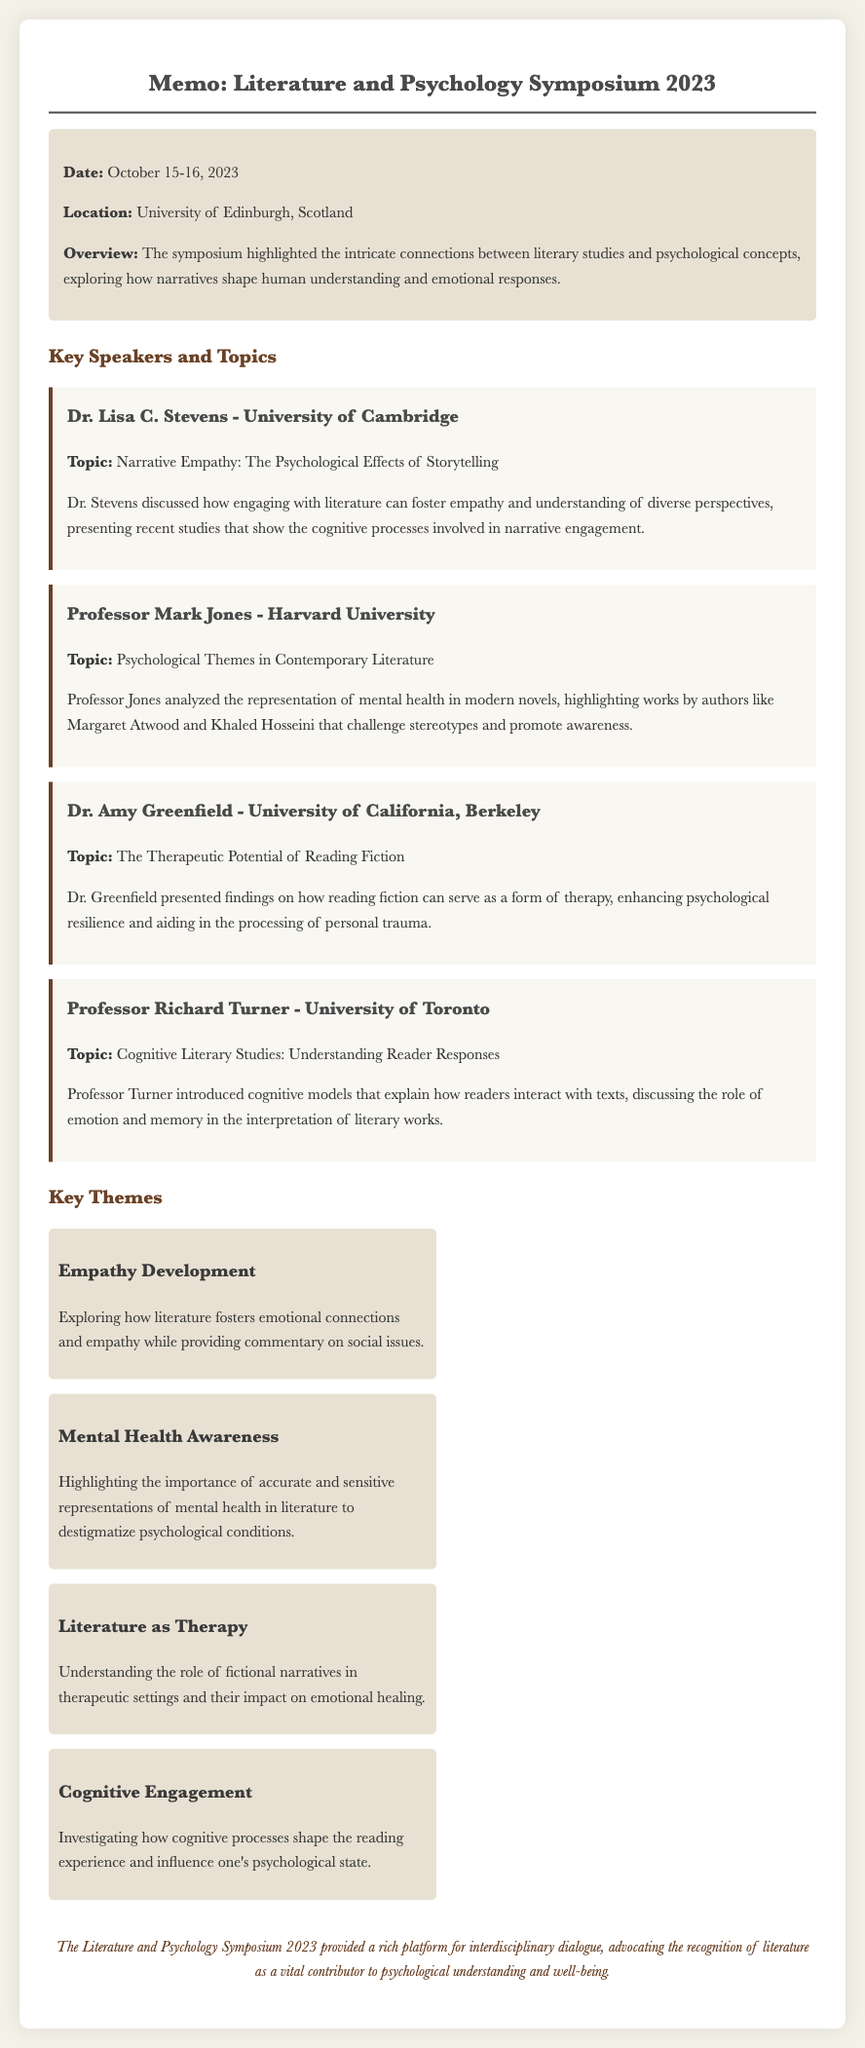What were the dates of the symposium? The dates of the symposium are mentioned in the document as October 15-16, 2023.
Answer: October 15-16, 2023 Who was the speaker from Harvard University? The document provides a list of speakers and identifies Professor Mark Jones as the speaker from Harvard University.
Answer: Professor Mark Jones What was Dr. Amy Greenfield's topic? The topic for Dr. Amy Greenfield is stated as "The Therapeutic Potential of Reading Fiction."
Answer: The Therapeutic Potential of Reading Fiction Which university did Dr. Lisa C. Stevens represent? The document mentions Dr. Lisa C. Stevens as representing the University of Cambridge.
Answer: University of Cambridge What key theme discusses the importance of mental health representations? The theme discussing mental health is titled "Mental Health Awareness" in the document.
Answer: Mental Health Awareness What cognitive aspect does Professor Richard Turner focus on regarding reader interactions? Professor Richard Turner discusses cognitive models that explain how readers interact with texts, related to emotion and memory.
Answer: Emotion and memory What is the significance of literature according to the conclusion of the memo? The conclusion emphasizes literature as a vital contributor to psychological understanding and well-being.
Answer: A vital contributor to psychological understanding and well-being What topic did Professor Mark Jones analyze? Professor Mark Jones analyzed the representation of mental health in modern novels.
Answer: Representation of mental health in modern novels 